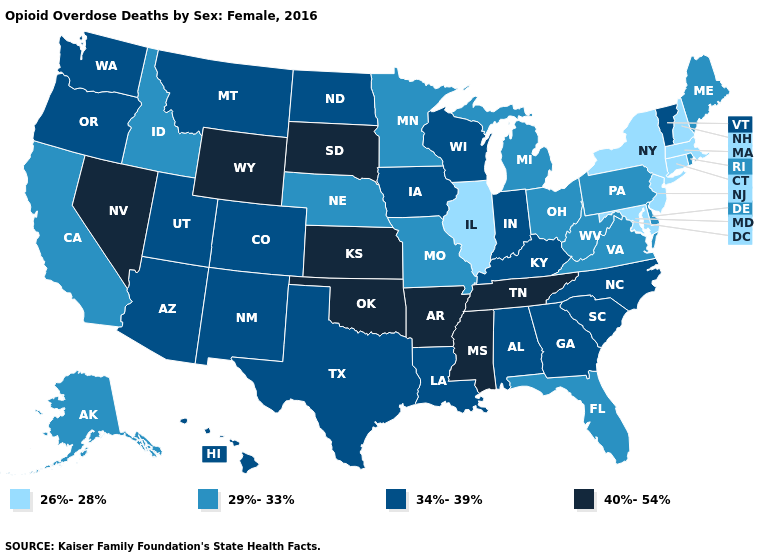Which states have the highest value in the USA?
Give a very brief answer. Arkansas, Kansas, Mississippi, Nevada, Oklahoma, South Dakota, Tennessee, Wyoming. Among the states that border Iowa , which have the lowest value?
Answer briefly. Illinois. Does the map have missing data?
Write a very short answer. No. What is the value of West Virginia?
Be succinct. 29%-33%. Name the states that have a value in the range 26%-28%?
Quick response, please. Connecticut, Illinois, Maryland, Massachusetts, New Hampshire, New Jersey, New York. Name the states that have a value in the range 26%-28%?
Answer briefly. Connecticut, Illinois, Maryland, Massachusetts, New Hampshire, New Jersey, New York. Name the states that have a value in the range 29%-33%?
Concise answer only. Alaska, California, Delaware, Florida, Idaho, Maine, Michigan, Minnesota, Missouri, Nebraska, Ohio, Pennsylvania, Rhode Island, Virginia, West Virginia. Does Idaho have the same value as Nevada?
Keep it brief. No. What is the value of Wyoming?
Write a very short answer. 40%-54%. Does Missouri have a lower value than Pennsylvania?
Keep it brief. No. Name the states that have a value in the range 29%-33%?
Give a very brief answer. Alaska, California, Delaware, Florida, Idaho, Maine, Michigan, Minnesota, Missouri, Nebraska, Ohio, Pennsylvania, Rhode Island, Virginia, West Virginia. What is the lowest value in the Northeast?
Give a very brief answer. 26%-28%. Name the states that have a value in the range 26%-28%?
Be succinct. Connecticut, Illinois, Maryland, Massachusetts, New Hampshire, New Jersey, New York. Name the states that have a value in the range 34%-39%?
Concise answer only. Alabama, Arizona, Colorado, Georgia, Hawaii, Indiana, Iowa, Kentucky, Louisiana, Montana, New Mexico, North Carolina, North Dakota, Oregon, South Carolina, Texas, Utah, Vermont, Washington, Wisconsin. Among the states that border Nevada , does Utah have the lowest value?
Concise answer only. No. 